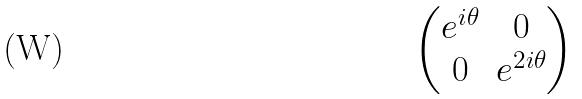<formula> <loc_0><loc_0><loc_500><loc_500>\begin{pmatrix} e ^ { i \theta } & 0 \\ 0 & e ^ { 2 i \theta } \end{pmatrix}</formula> 